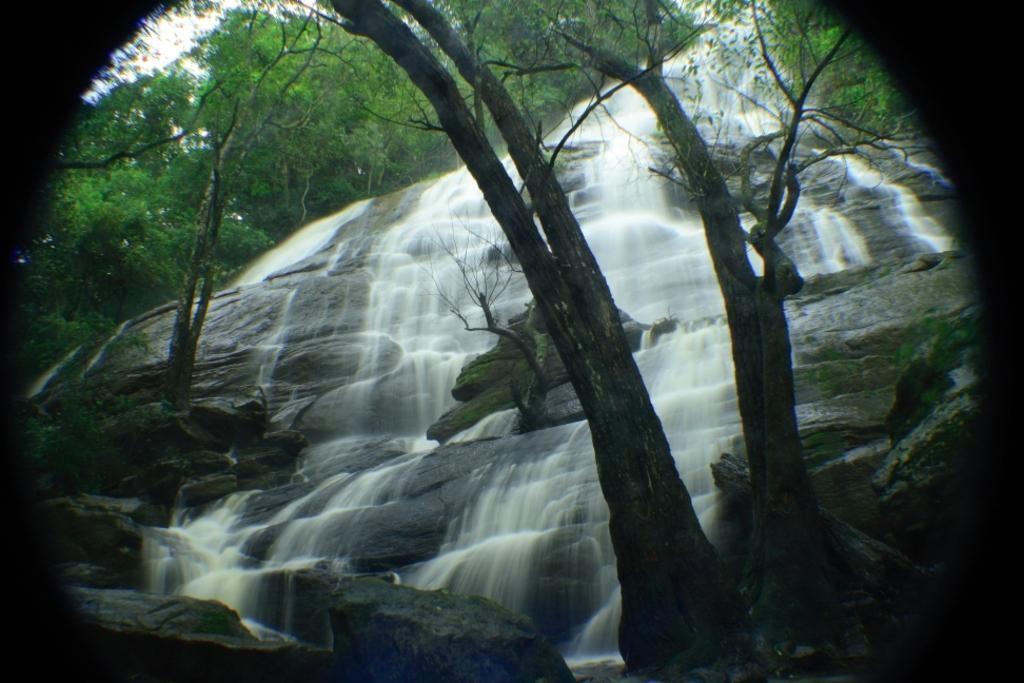What is the main feature of the image that has been edited? The image appears to be edited, but the specific feature cannot be determined from the provided facts. What natural feature can be seen in the image? There is a waterfall in the image. What type of vegetation is present in the image? There are trees with branches and leaves in the image. Where is the water originating from in the image? Water is flowing from a hill in the image. How many girls are holding a bottle in the image? There are no girls or bottles present in the image. 